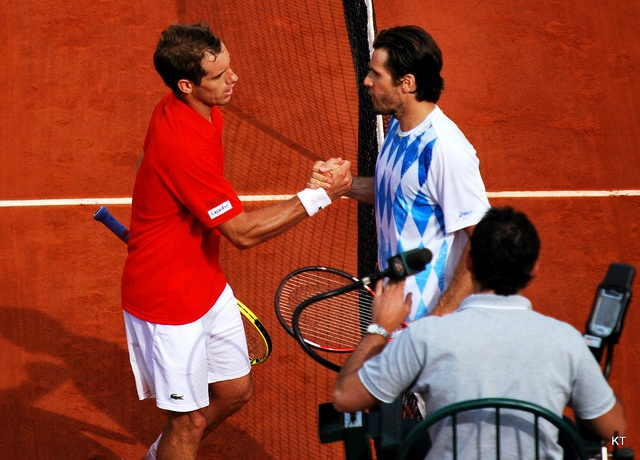Describe the objects in this image and their specific colors. I can see people in brown, red, lavender, and maroon tones, people in brown, lightgray, black, and darkgray tones, people in brown, lavender, black, and maroon tones, chair in brown, black, darkgray, gray, and purple tones, and tennis racket in brown and black tones in this image. 